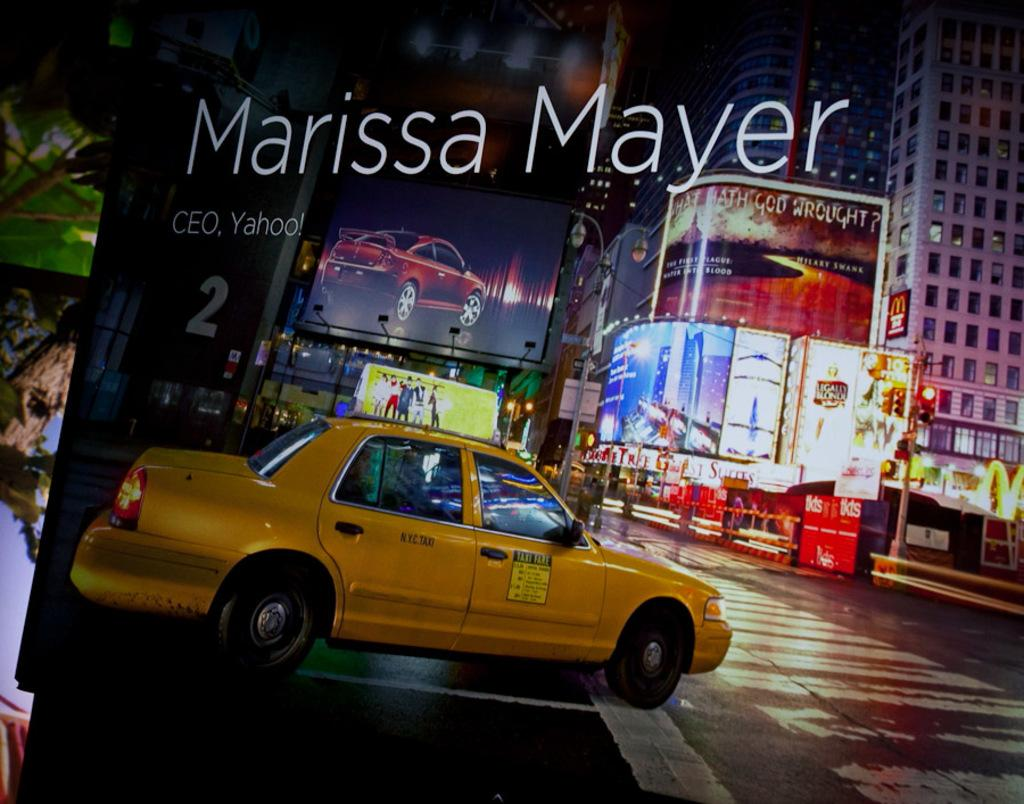<image>
Summarize the visual content of the image. A taxi waits at a street corner with colorful signs and billboards hanging from tall city buildings. 